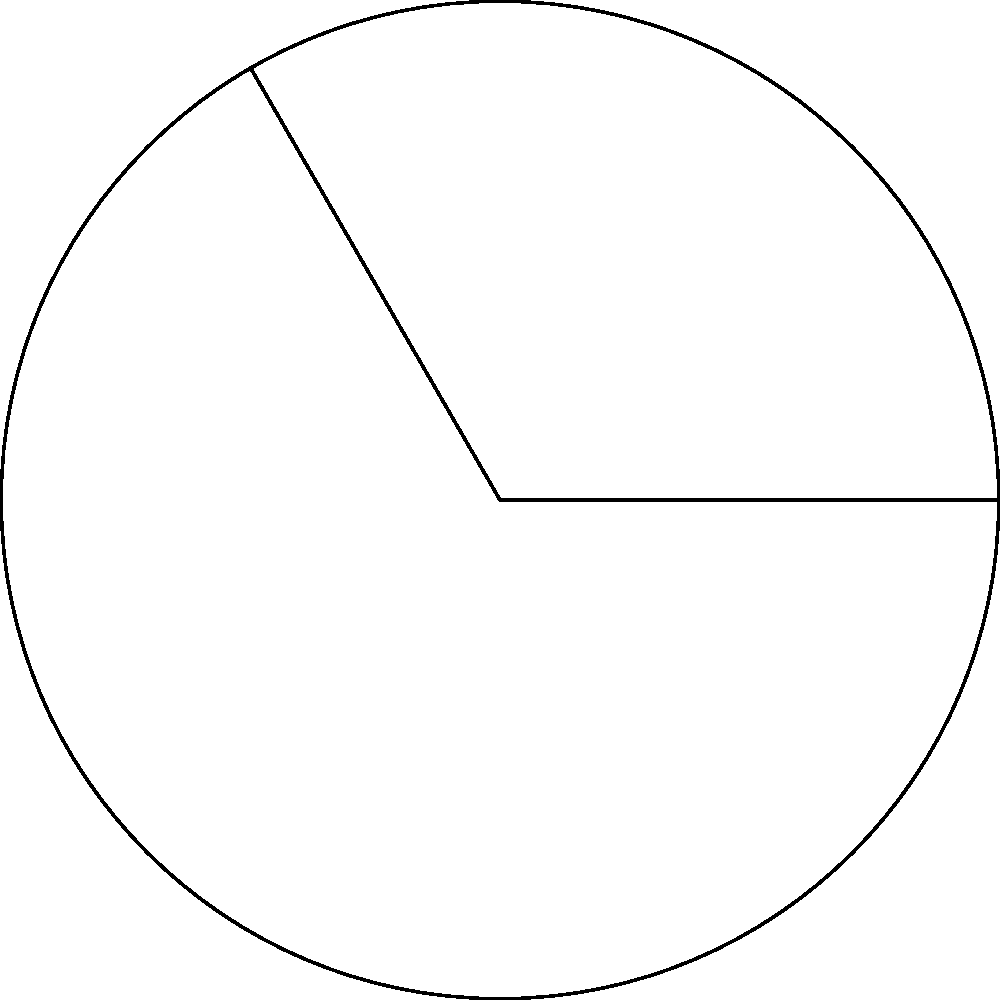In a scene from "2001: A Space Odyssey," there's a circular display panel with a sector highlighted. If the radius of the panel is 3 units and the central angle of the highlighted sector is 120°, what is the area of this sector? (Use $\pi = 3.14$ for calculations) To find the area of a circular sector, we can follow these steps:

1) The formula for the area of a circular sector is:

   $$A = \frac{\theta}{360°} \cdot \pi r^2$$

   where $\theta$ is the central angle in degrees, and $r$ is the radius.

2) We're given:
   - Radius $r = 3$ units
   - Central angle $\theta = 120°$
   - $\pi = 3.14$

3) Let's substitute these values into our formula:

   $$A = \frac{120°}{360°} \cdot 3.14 \cdot 3^2$$

4) Simplify:
   $$A = \frac{1}{3} \cdot 3.14 \cdot 9$$
   $$A = 9.42$$

5) Therefore, the area of the sector is approximately 9.42 square units.

This circular sector could represent the portion of the HAL 9000's "eye" that's illuminated during a crucial scene, symbolizing the 120° field of view of the computer's camera system.
Answer: 9.42 square units 